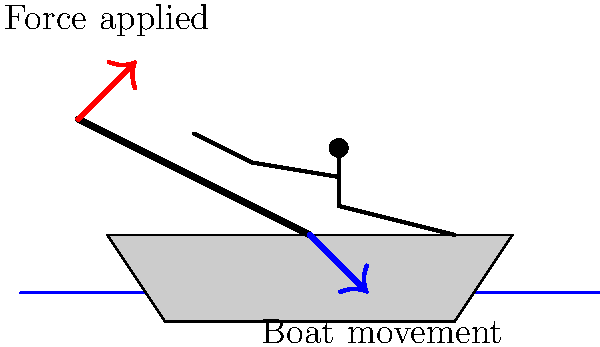In traditional Scottish fishing boats, the rowing technique often involved a specific biomechanical principle to maximize efficiency. Which principle is demonstrated in the diagram, and how does it relate to the boat's movement through water? To understand the biomechanics of rowing in traditional Scottish fishing boats, let's break down the diagram and the principles involved:

1. Lever system: The oar acts as a lever, with the oarlock (not shown, but implied where the oar meets the boat) serving as the fulcrum.

2. Force application: The rower applies force at the handle of the oar (red arrow), creating a moment around the fulcrum.

3. Resistance: The water provides resistance against the blade of the oar.

4. Boat movement: The blue arrow shows the direction of the boat's movement.

5. Mechanical advantage: The oar's length provides a mechanical advantage, allowing the rower to move a large mass of water with less effort.

The key principle demonstrated here is the Third-Class Lever system. In this system:
- The effort (rower's force) is between the fulcrum (oarlock) and the load (water resistance).
- This arrangement sacrifices force for speed and range of motion.

The biomechanical efficiency comes from:
a) The long oar provides a greater moment arm for the applied force.
b) The rower's body positioning allows for the use of larger muscle groups (legs, back) in addition to arms.
c) The oar's angle in the water creates a backward thrust, propelling the boat forward.

This technique allows for efficient energy transfer from the rower to the boat's movement through water, which was crucial for Scottish fishermen who often needed to cover long distances or maneuver in challenging coastal waters.
Answer: Third-Class Lever system maximizing mechanical advantage and energy transfer 